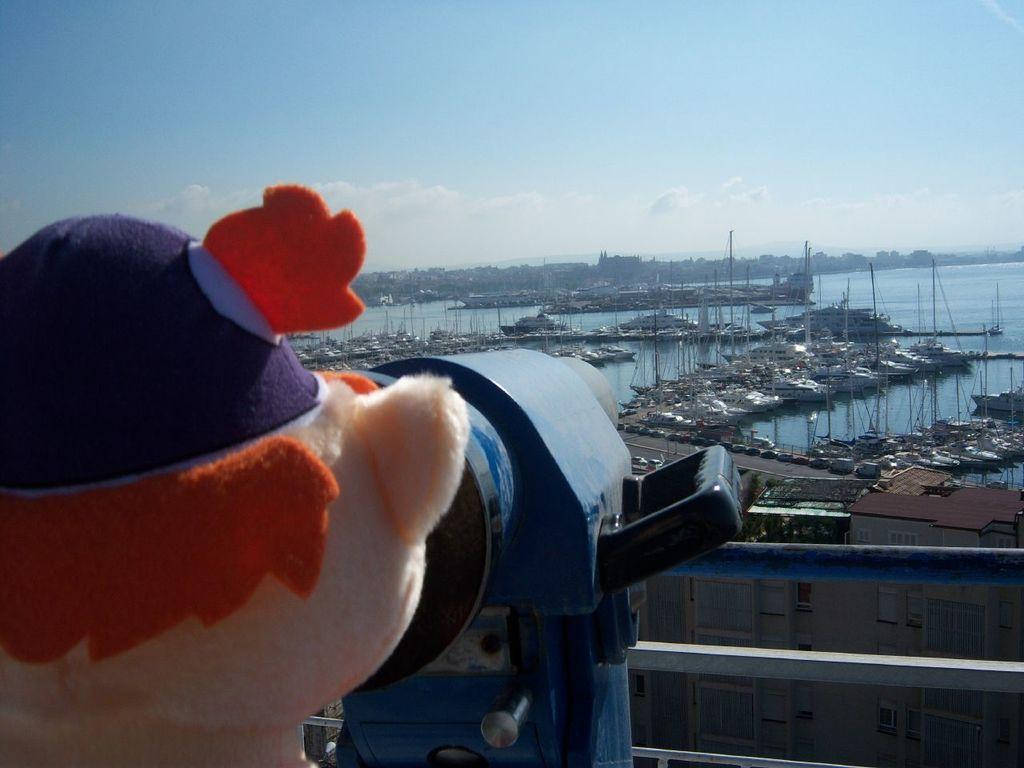What can be seen in the image that is not a vehicle or a boat? There is a toy in the image. Can you describe the object in the image? There is an object in the image, but its description is not provided in the facts. What type of vehicles are on the road in the image? The facts do not specify the type of vehicles on the road. What is the water visible in the image used for? The facts do not specify the purpose of the water. What is visible in the background of the image? The sky is visible in the background of the image, and there are clouds in the sky. What type of apparel is the toy wearing in the image? The facts do not mention any apparel on the toy in the image. Can you tell me where the faucet is located in the image? There is no faucet present in the image. What type of rifle is being used by the boats in the image? There are no rifles present in the image, and boats do not use rifles. 